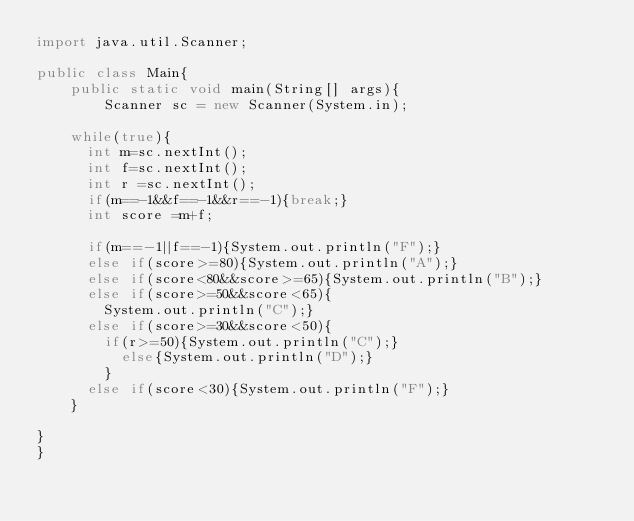<code> <loc_0><loc_0><loc_500><loc_500><_Java_>import java.util.Scanner;
 
public class Main{
    public static void main(String[] args){
        Scanner sc = new Scanner(System.in);
		
		while(true){
			int m=sc.nextInt();
			int f=sc.nextInt();
			int r =sc.nextInt();
			if(m==-1&&f==-1&&r==-1){break;}
			int score =m+f;
			
			if(m==-1||f==-1){System.out.println("F");}
			else if(score>=80){System.out.println("A");}
			else if(score<80&&score>=65){System.out.println("B");}
			else if(score>=50&&score<65){
				System.out.println("C");}
			else if(score>=30&&score<50){
				if(r>=50){System.out.println("C");}
					else{System.out.println("D");}
				}
			else if(score<30){System.out.println("F");}
		}

}    
}</code> 